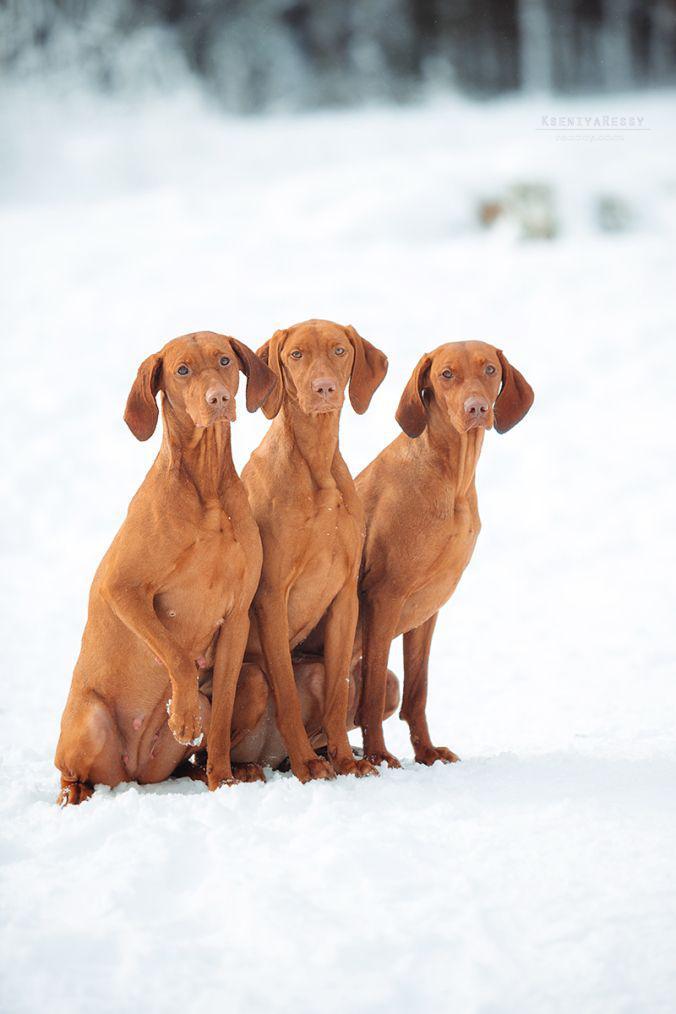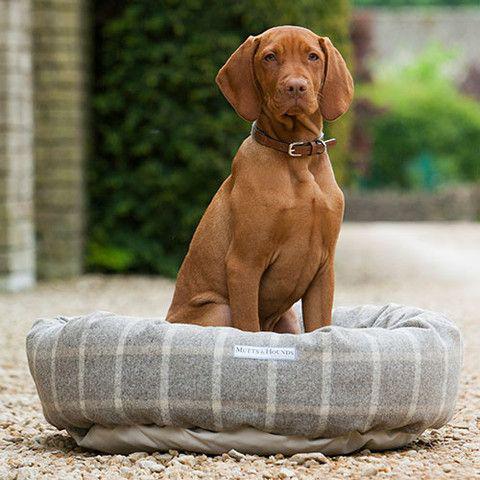The first image is the image on the left, the second image is the image on the right. Assess this claim about the two images: "There are at least three dogs in total.". Correct or not? Answer yes or no. Yes. The first image is the image on the left, the second image is the image on the right. Assess this claim about the two images: "Left and right images show an orange dog at the beach, and at least one image shows a dog that is not in the water.". Correct or not? Answer yes or no. No. 